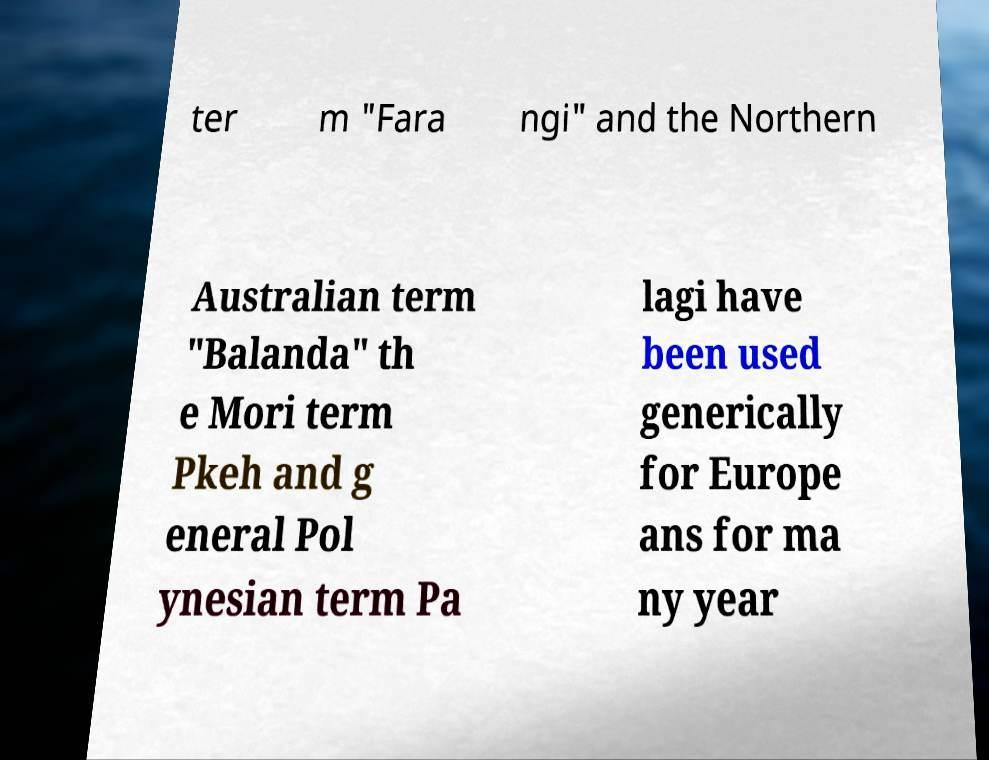I need the written content from this picture converted into text. Can you do that? ter m "Fara ngi" and the Northern Australian term "Balanda" th e Mori term Pkeh and g eneral Pol ynesian term Pa lagi have been used generically for Europe ans for ma ny year 